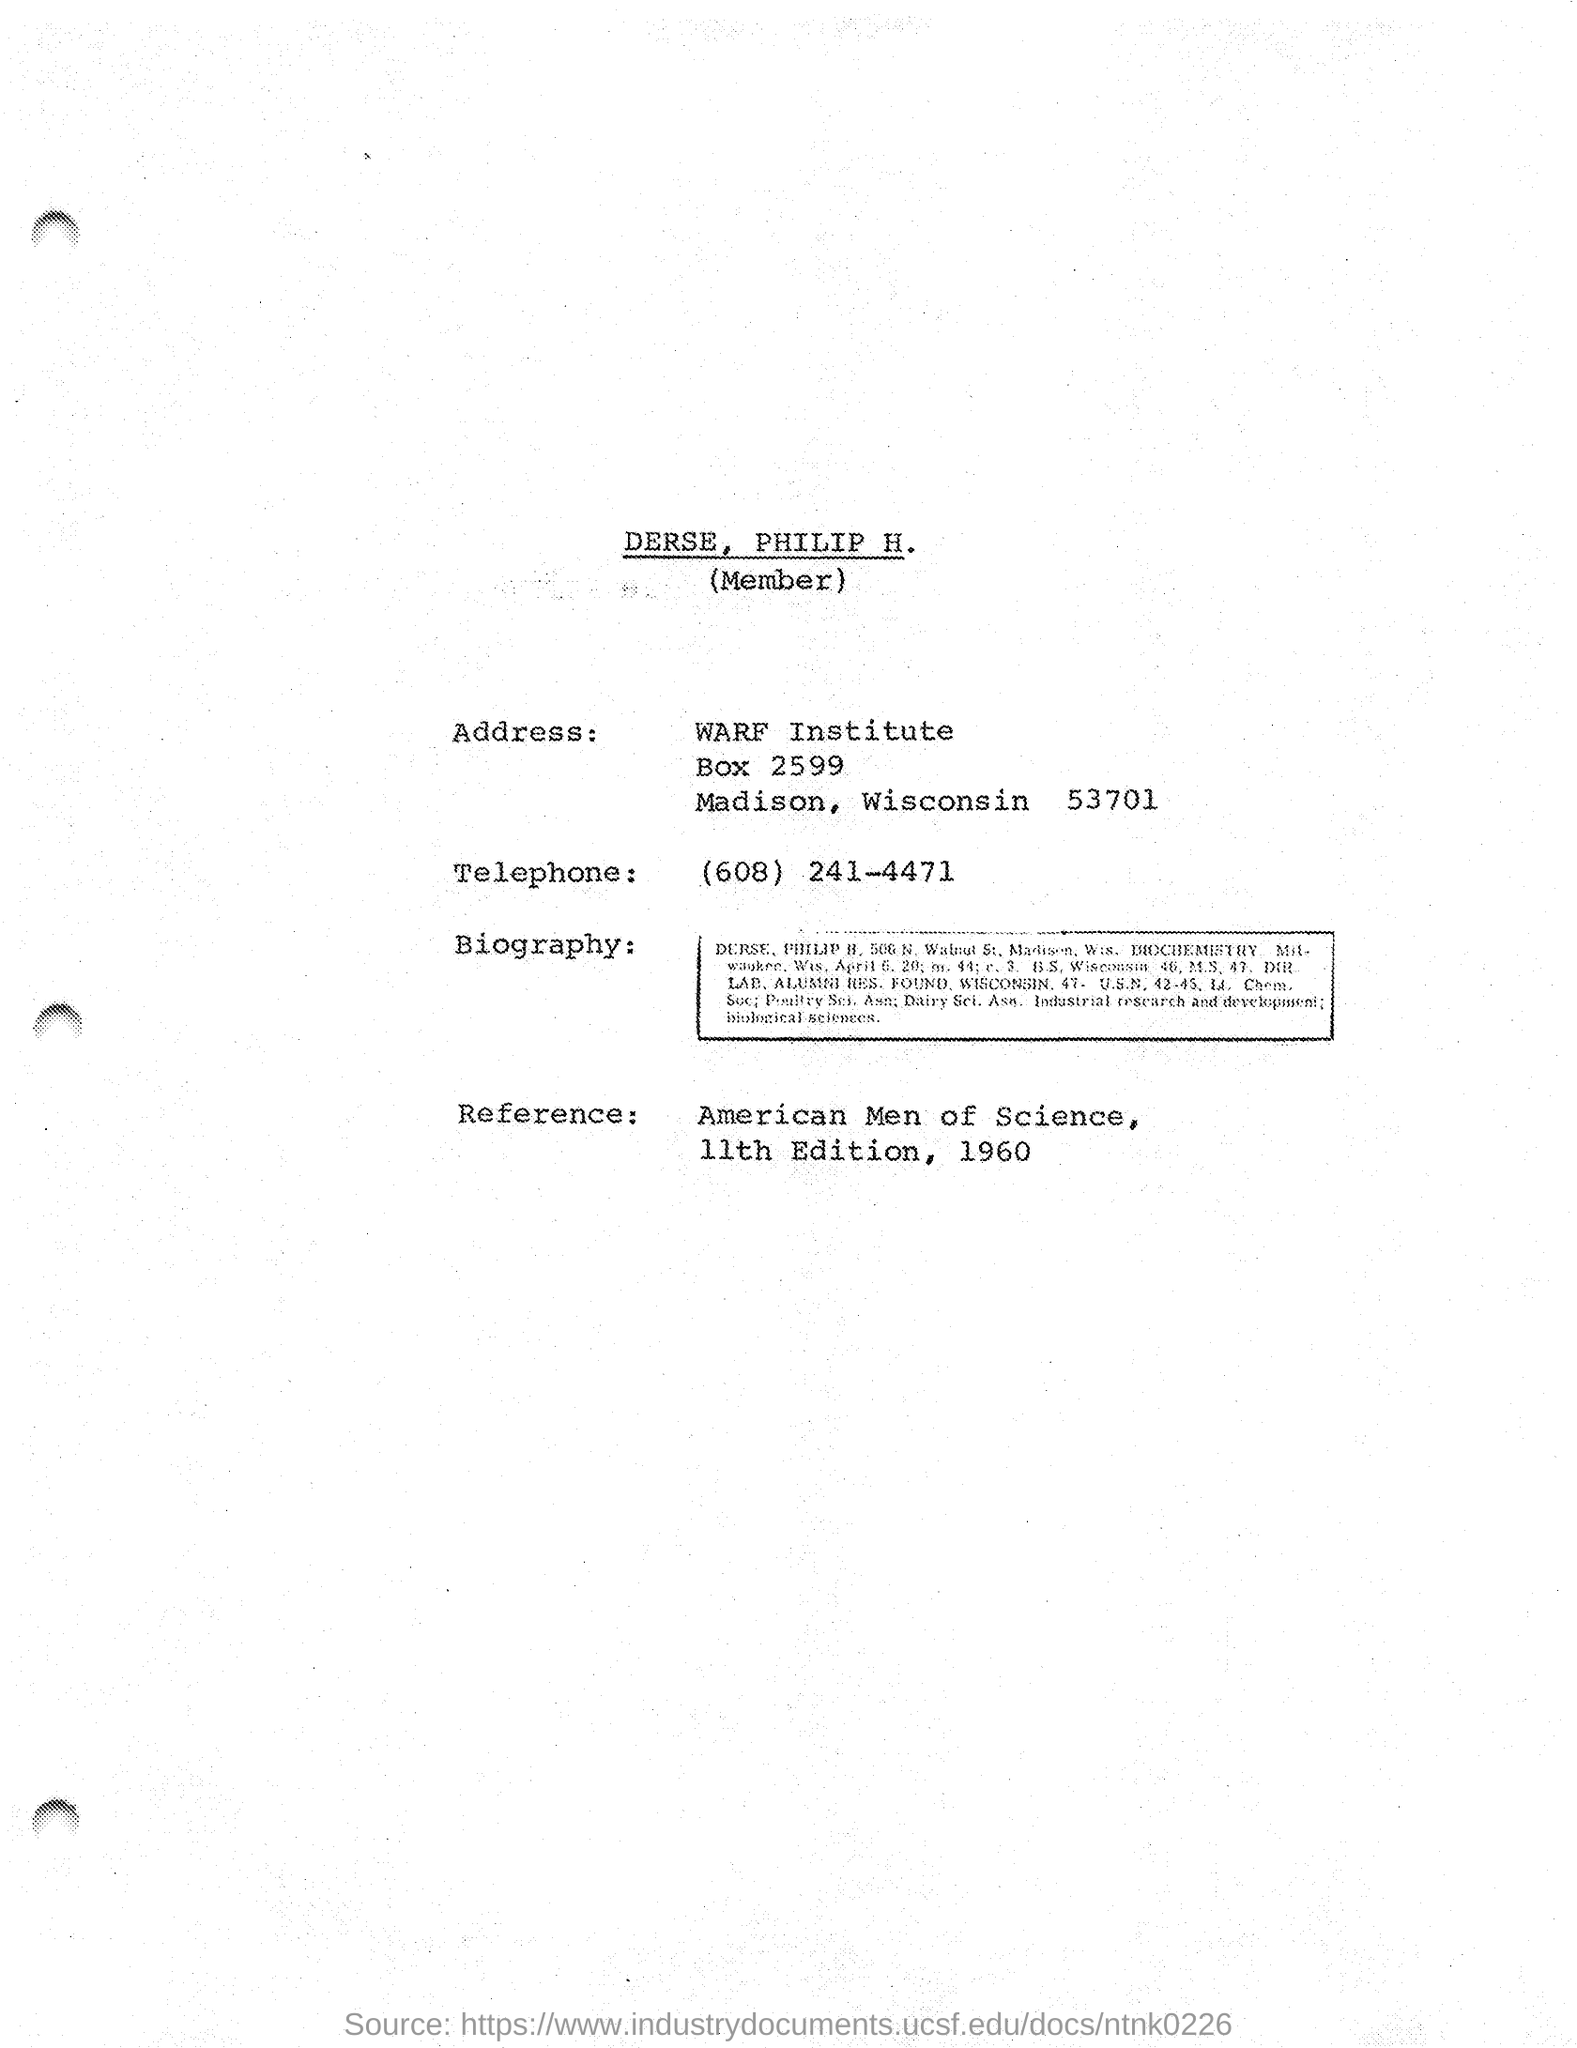Identify some key points in this picture. Philip H. Derser belongs to the city of Madison, Wisconsin. The reference provided in this document is American Men of Science, 11th Edition, which was published in 1960. The telephone number mentioned in this document is (608) 241-4471. The member referred to in this document is DERSE, and the name of the member is PHILIP H. 